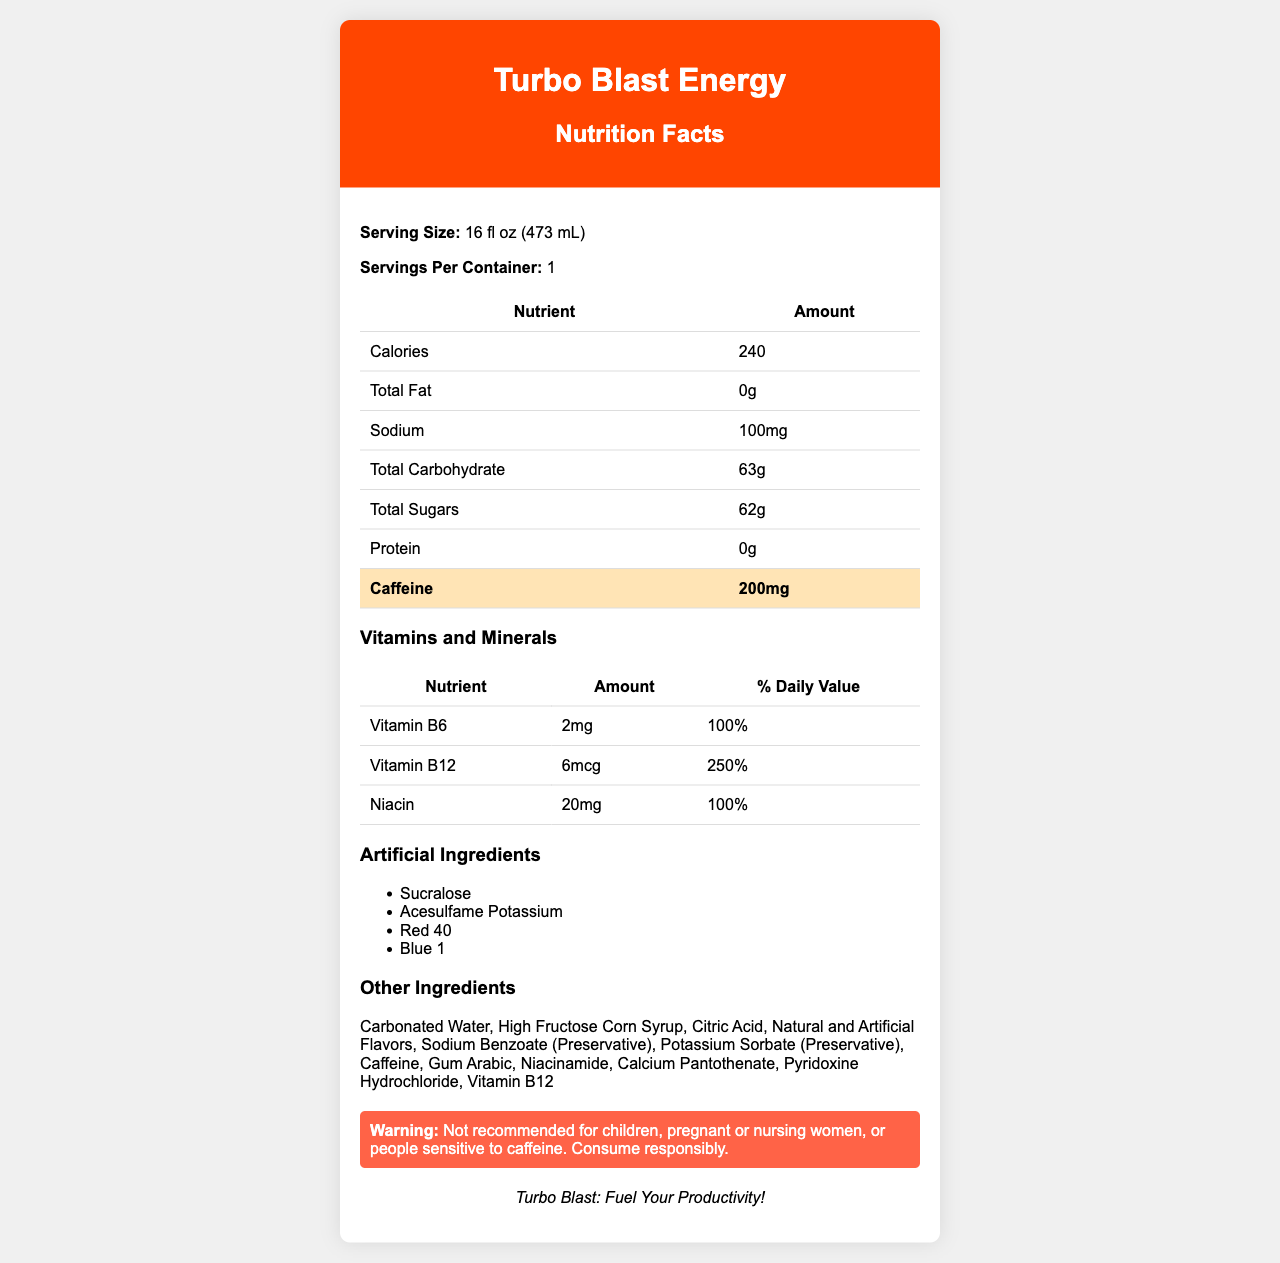what is the serving size of Turbo Blast Energy? The document indicates that the serving size for Turbo Blast Energy is 16 fl oz (473 mL).
Answer: 16 fl oz (473 mL) How many calories are in a serving of Turbo Blast Energy? The document states that one serving of the energy drink contains 240 calories.
Answer: 240 What is the caffeine content in Turbo Blast Energy? According to the document, Turbo Blast Energy contains 200mg of caffeine per serving.
Answer: 200mg Name one artificial ingredient used in Turbo Blast Energy. The document lists several artificial ingredients, including Sucralose.
Answer: Sucralose What is the percentage of daily value for Vitamin B12 in Turbo Blast Energy? The document shows that the amount of Vitamin B12 in the drink provides 250% of the daily recommended value.
Answer: 250% Which of the following ingredients is not listed under artificial ingredients? A. Sucralose B. Citric Acid C. Red 40 Citric Acid is listed under "other ingredients," while Sucralose and Red 40 are listed under "artificial ingredients."
Answer: B. Citric Acid How many grams of total sugars are in Turbo Blast Energy? A. 0g B. 20g C. 62g D. 100g The document states that Turbo Blast Energy contains 62 grams of total sugars per serving.
Answer: C. 62g Can children consume Turbo Blast Energy? The warning in the document states that the drink is not recommended for children, among others.
Answer: No Summarize the main idea of the Turbo Blast Energy nutrition facts label. Turbo Blast Energy is an energy drink with a high caffeine content aimed at enhancing productivity. It contains several artificial ingredients for cost-effectiveness and shelf life, essential vitamins B6, B12, and Niacin, but emphasizes minimal nutritional benefits. There is also a warning regarding its consumption.
Answer: Turbo Blast Energy: This energy drink has a high caffeine content and includes several artificial ingredients to provide a cost-effective and long-lasting product, appealing primarily to productivity-focused consumers. It also contains essential vitamins and minerals but minimal nutritional benefits overall. What specific steps were taken to accelerate the product launch of Turbo Blast Energy? The document does not provide specific details on the steps taken to accelerate the product launch aside from stating that quality control steps were reduced.
Answer: Cannot be determined 